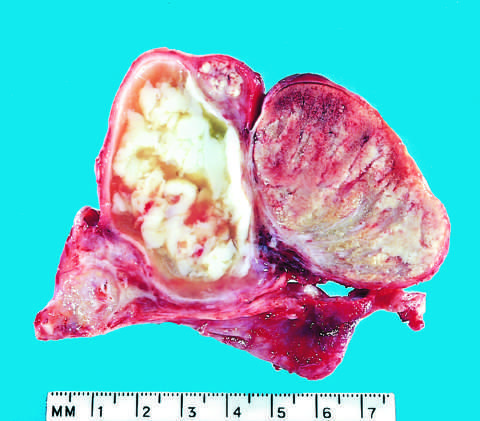s acute epididymitis caused by gonococcal infection?
Answer the question using a single word or phrase. Yes 